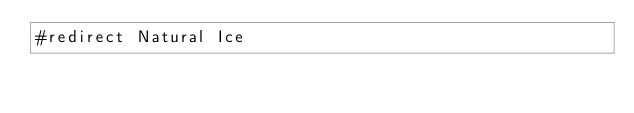Convert code to text. <code><loc_0><loc_0><loc_500><loc_500><_FORTRAN_>#redirect Natural Ice
</code> 